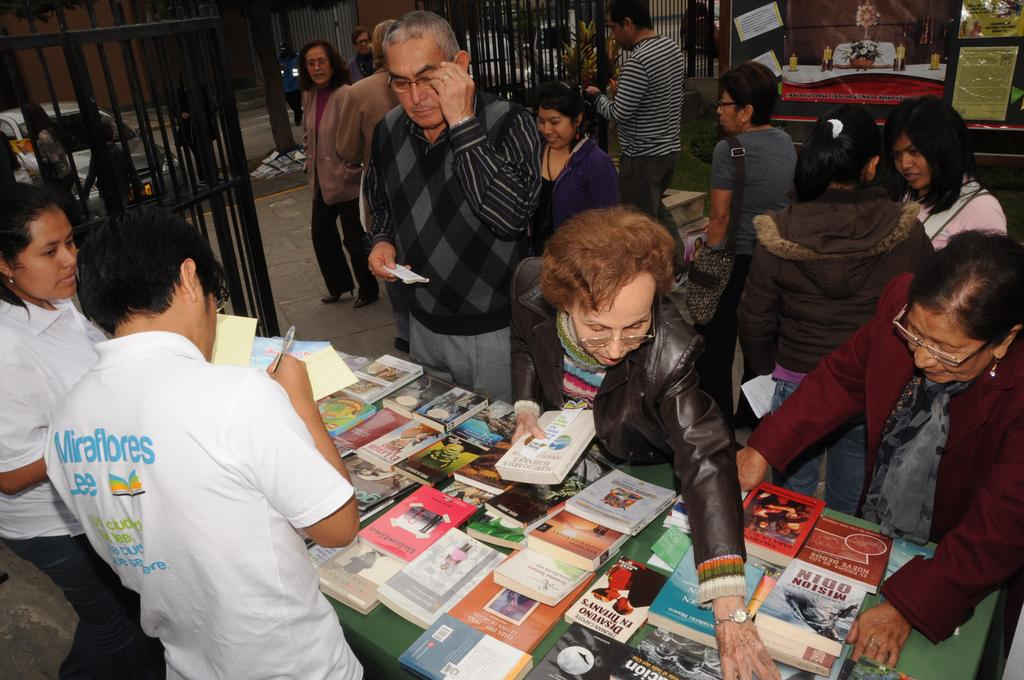Provide a one-sentence caption for the provided image. A group of people are selecting books from a table of many titles, including El Largo. 